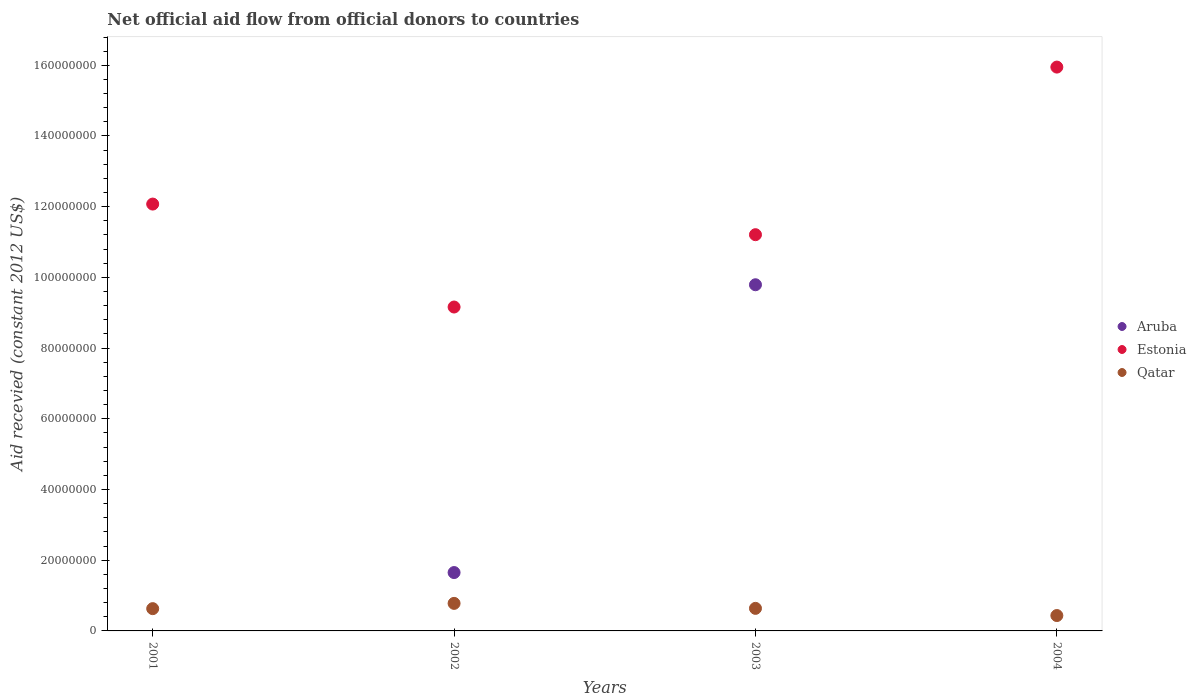How many different coloured dotlines are there?
Give a very brief answer. 3. Is the number of dotlines equal to the number of legend labels?
Your answer should be very brief. No. What is the total aid received in Estonia in 2003?
Keep it short and to the point. 1.12e+08. Across all years, what is the maximum total aid received in Estonia?
Ensure brevity in your answer.  1.59e+08. Across all years, what is the minimum total aid received in Qatar?
Ensure brevity in your answer.  4.35e+06. In which year was the total aid received in Estonia maximum?
Provide a short and direct response. 2004. What is the total total aid received in Aruba in the graph?
Provide a succinct answer. 1.14e+08. What is the difference between the total aid received in Estonia in 2002 and that in 2003?
Your response must be concise. -2.05e+07. What is the difference between the total aid received in Aruba in 2003 and the total aid received in Qatar in 2001?
Your answer should be very brief. 9.16e+07. What is the average total aid received in Aruba per year?
Make the answer very short. 2.86e+07. In the year 2002, what is the difference between the total aid received in Estonia and total aid received in Qatar?
Make the answer very short. 8.38e+07. What is the ratio of the total aid received in Estonia in 2001 to that in 2003?
Provide a short and direct response. 1.08. What is the difference between the highest and the second highest total aid received in Estonia?
Keep it short and to the point. 3.88e+07. What is the difference between the highest and the lowest total aid received in Qatar?
Your answer should be very brief. 3.44e+06. In how many years, is the total aid received in Estonia greater than the average total aid received in Estonia taken over all years?
Keep it short and to the point. 1. Is the sum of the total aid received in Qatar in 2001 and 2002 greater than the maximum total aid received in Aruba across all years?
Your response must be concise. No. Does the total aid received in Qatar monotonically increase over the years?
Provide a succinct answer. No. How many years are there in the graph?
Your response must be concise. 4. Does the graph contain any zero values?
Ensure brevity in your answer.  Yes. How many legend labels are there?
Make the answer very short. 3. How are the legend labels stacked?
Your answer should be very brief. Vertical. What is the title of the graph?
Your answer should be compact. Net official aid flow from official donors to countries. Does "Cambodia" appear as one of the legend labels in the graph?
Offer a very short reply. No. What is the label or title of the X-axis?
Your answer should be compact. Years. What is the label or title of the Y-axis?
Make the answer very short. Aid recevied (constant 2012 US$). What is the Aid recevied (constant 2012 US$) in Aruba in 2001?
Ensure brevity in your answer.  0. What is the Aid recevied (constant 2012 US$) in Estonia in 2001?
Offer a very short reply. 1.21e+08. What is the Aid recevied (constant 2012 US$) in Qatar in 2001?
Provide a succinct answer. 6.30e+06. What is the Aid recevied (constant 2012 US$) of Aruba in 2002?
Give a very brief answer. 1.65e+07. What is the Aid recevied (constant 2012 US$) of Estonia in 2002?
Your response must be concise. 9.16e+07. What is the Aid recevied (constant 2012 US$) in Qatar in 2002?
Give a very brief answer. 7.79e+06. What is the Aid recevied (constant 2012 US$) of Aruba in 2003?
Make the answer very short. 9.79e+07. What is the Aid recevied (constant 2012 US$) in Estonia in 2003?
Provide a succinct answer. 1.12e+08. What is the Aid recevied (constant 2012 US$) in Qatar in 2003?
Your answer should be very brief. 6.38e+06. What is the Aid recevied (constant 2012 US$) of Aruba in 2004?
Keep it short and to the point. 0. What is the Aid recevied (constant 2012 US$) in Estonia in 2004?
Ensure brevity in your answer.  1.59e+08. What is the Aid recevied (constant 2012 US$) in Qatar in 2004?
Provide a succinct answer. 4.35e+06. Across all years, what is the maximum Aid recevied (constant 2012 US$) in Aruba?
Your answer should be compact. 9.79e+07. Across all years, what is the maximum Aid recevied (constant 2012 US$) of Estonia?
Give a very brief answer. 1.59e+08. Across all years, what is the maximum Aid recevied (constant 2012 US$) in Qatar?
Make the answer very short. 7.79e+06. Across all years, what is the minimum Aid recevied (constant 2012 US$) in Aruba?
Offer a terse response. 0. Across all years, what is the minimum Aid recevied (constant 2012 US$) of Estonia?
Your answer should be compact. 9.16e+07. Across all years, what is the minimum Aid recevied (constant 2012 US$) of Qatar?
Ensure brevity in your answer.  4.35e+06. What is the total Aid recevied (constant 2012 US$) in Aruba in the graph?
Ensure brevity in your answer.  1.14e+08. What is the total Aid recevied (constant 2012 US$) of Estonia in the graph?
Your answer should be very brief. 4.84e+08. What is the total Aid recevied (constant 2012 US$) of Qatar in the graph?
Offer a terse response. 2.48e+07. What is the difference between the Aid recevied (constant 2012 US$) in Estonia in 2001 and that in 2002?
Your answer should be compact. 2.91e+07. What is the difference between the Aid recevied (constant 2012 US$) in Qatar in 2001 and that in 2002?
Offer a very short reply. -1.49e+06. What is the difference between the Aid recevied (constant 2012 US$) of Estonia in 2001 and that in 2003?
Offer a very short reply. 8.66e+06. What is the difference between the Aid recevied (constant 2012 US$) in Qatar in 2001 and that in 2003?
Offer a terse response. -8.00e+04. What is the difference between the Aid recevied (constant 2012 US$) of Estonia in 2001 and that in 2004?
Keep it short and to the point. -3.88e+07. What is the difference between the Aid recevied (constant 2012 US$) in Qatar in 2001 and that in 2004?
Make the answer very short. 1.95e+06. What is the difference between the Aid recevied (constant 2012 US$) of Aruba in 2002 and that in 2003?
Provide a short and direct response. -8.14e+07. What is the difference between the Aid recevied (constant 2012 US$) in Estonia in 2002 and that in 2003?
Your answer should be very brief. -2.05e+07. What is the difference between the Aid recevied (constant 2012 US$) of Qatar in 2002 and that in 2003?
Keep it short and to the point. 1.41e+06. What is the difference between the Aid recevied (constant 2012 US$) in Estonia in 2002 and that in 2004?
Provide a short and direct response. -6.79e+07. What is the difference between the Aid recevied (constant 2012 US$) in Qatar in 2002 and that in 2004?
Make the answer very short. 3.44e+06. What is the difference between the Aid recevied (constant 2012 US$) in Estonia in 2003 and that in 2004?
Your response must be concise. -4.74e+07. What is the difference between the Aid recevied (constant 2012 US$) in Qatar in 2003 and that in 2004?
Keep it short and to the point. 2.03e+06. What is the difference between the Aid recevied (constant 2012 US$) in Estonia in 2001 and the Aid recevied (constant 2012 US$) in Qatar in 2002?
Keep it short and to the point. 1.13e+08. What is the difference between the Aid recevied (constant 2012 US$) of Estonia in 2001 and the Aid recevied (constant 2012 US$) of Qatar in 2003?
Provide a short and direct response. 1.14e+08. What is the difference between the Aid recevied (constant 2012 US$) of Estonia in 2001 and the Aid recevied (constant 2012 US$) of Qatar in 2004?
Offer a terse response. 1.16e+08. What is the difference between the Aid recevied (constant 2012 US$) in Aruba in 2002 and the Aid recevied (constant 2012 US$) in Estonia in 2003?
Keep it short and to the point. -9.56e+07. What is the difference between the Aid recevied (constant 2012 US$) of Aruba in 2002 and the Aid recevied (constant 2012 US$) of Qatar in 2003?
Your answer should be very brief. 1.01e+07. What is the difference between the Aid recevied (constant 2012 US$) in Estonia in 2002 and the Aid recevied (constant 2012 US$) in Qatar in 2003?
Keep it short and to the point. 8.52e+07. What is the difference between the Aid recevied (constant 2012 US$) in Aruba in 2002 and the Aid recevied (constant 2012 US$) in Estonia in 2004?
Offer a very short reply. -1.43e+08. What is the difference between the Aid recevied (constant 2012 US$) in Aruba in 2002 and the Aid recevied (constant 2012 US$) in Qatar in 2004?
Provide a succinct answer. 1.22e+07. What is the difference between the Aid recevied (constant 2012 US$) of Estonia in 2002 and the Aid recevied (constant 2012 US$) of Qatar in 2004?
Provide a short and direct response. 8.73e+07. What is the difference between the Aid recevied (constant 2012 US$) of Aruba in 2003 and the Aid recevied (constant 2012 US$) of Estonia in 2004?
Ensure brevity in your answer.  -6.16e+07. What is the difference between the Aid recevied (constant 2012 US$) of Aruba in 2003 and the Aid recevied (constant 2012 US$) of Qatar in 2004?
Make the answer very short. 9.36e+07. What is the difference between the Aid recevied (constant 2012 US$) of Estonia in 2003 and the Aid recevied (constant 2012 US$) of Qatar in 2004?
Keep it short and to the point. 1.08e+08. What is the average Aid recevied (constant 2012 US$) of Aruba per year?
Make the answer very short. 2.86e+07. What is the average Aid recevied (constant 2012 US$) of Estonia per year?
Your answer should be very brief. 1.21e+08. What is the average Aid recevied (constant 2012 US$) in Qatar per year?
Keep it short and to the point. 6.20e+06. In the year 2001, what is the difference between the Aid recevied (constant 2012 US$) in Estonia and Aid recevied (constant 2012 US$) in Qatar?
Offer a very short reply. 1.14e+08. In the year 2002, what is the difference between the Aid recevied (constant 2012 US$) of Aruba and Aid recevied (constant 2012 US$) of Estonia?
Your answer should be compact. -7.51e+07. In the year 2002, what is the difference between the Aid recevied (constant 2012 US$) of Aruba and Aid recevied (constant 2012 US$) of Qatar?
Provide a succinct answer. 8.72e+06. In the year 2002, what is the difference between the Aid recevied (constant 2012 US$) in Estonia and Aid recevied (constant 2012 US$) in Qatar?
Ensure brevity in your answer.  8.38e+07. In the year 2003, what is the difference between the Aid recevied (constant 2012 US$) of Aruba and Aid recevied (constant 2012 US$) of Estonia?
Make the answer very short. -1.42e+07. In the year 2003, what is the difference between the Aid recevied (constant 2012 US$) of Aruba and Aid recevied (constant 2012 US$) of Qatar?
Make the answer very short. 9.15e+07. In the year 2003, what is the difference between the Aid recevied (constant 2012 US$) in Estonia and Aid recevied (constant 2012 US$) in Qatar?
Offer a terse response. 1.06e+08. In the year 2004, what is the difference between the Aid recevied (constant 2012 US$) in Estonia and Aid recevied (constant 2012 US$) in Qatar?
Keep it short and to the point. 1.55e+08. What is the ratio of the Aid recevied (constant 2012 US$) of Estonia in 2001 to that in 2002?
Keep it short and to the point. 1.32. What is the ratio of the Aid recevied (constant 2012 US$) in Qatar in 2001 to that in 2002?
Offer a terse response. 0.81. What is the ratio of the Aid recevied (constant 2012 US$) in Estonia in 2001 to that in 2003?
Make the answer very short. 1.08. What is the ratio of the Aid recevied (constant 2012 US$) in Qatar in 2001 to that in 2003?
Your response must be concise. 0.99. What is the ratio of the Aid recevied (constant 2012 US$) of Estonia in 2001 to that in 2004?
Your answer should be very brief. 0.76. What is the ratio of the Aid recevied (constant 2012 US$) in Qatar in 2001 to that in 2004?
Your answer should be compact. 1.45. What is the ratio of the Aid recevied (constant 2012 US$) of Aruba in 2002 to that in 2003?
Your answer should be compact. 0.17. What is the ratio of the Aid recevied (constant 2012 US$) of Estonia in 2002 to that in 2003?
Offer a terse response. 0.82. What is the ratio of the Aid recevied (constant 2012 US$) of Qatar in 2002 to that in 2003?
Keep it short and to the point. 1.22. What is the ratio of the Aid recevied (constant 2012 US$) of Estonia in 2002 to that in 2004?
Your answer should be compact. 0.57. What is the ratio of the Aid recevied (constant 2012 US$) of Qatar in 2002 to that in 2004?
Provide a short and direct response. 1.79. What is the ratio of the Aid recevied (constant 2012 US$) of Estonia in 2003 to that in 2004?
Your answer should be very brief. 0.7. What is the ratio of the Aid recevied (constant 2012 US$) of Qatar in 2003 to that in 2004?
Your answer should be very brief. 1.47. What is the difference between the highest and the second highest Aid recevied (constant 2012 US$) of Estonia?
Make the answer very short. 3.88e+07. What is the difference between the highest and the second highest Aid recevied (constant 2012 US$) in Qatar?
Provide a short and direct response. 1.41e+06. What is the difference between the highest and the lowest Aid recevied (constant 2012 US$) in Aruba?
Provide a short and direct response. 9.79e+07. What is the difference between the highest and the lowest Aid recevied (constant 2012 US$) in Estonia?
Make the answer very short. 6.79e+07. What is the difference between the highest and the lowest Aid recevied (constant 2012 US$) in Qatar?
Ensure brevity in your answer.  3.44e+06. 